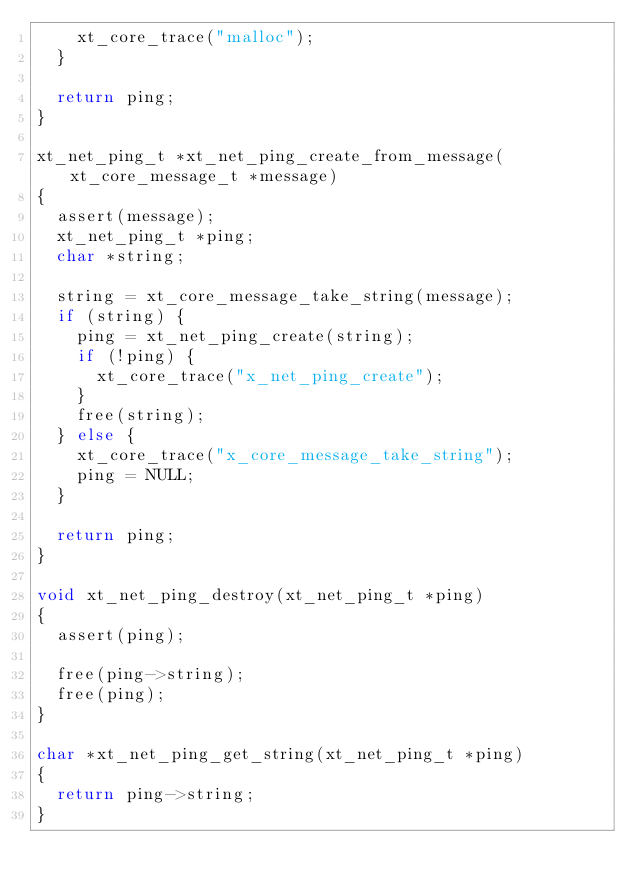<code> <loc_0><loc_0><loc_500><loc_500><_C_>    xt_core_trace("malloc");
  }

  return ping;
}

xt_net_ping_t *xt_net_ping_create_from_message(xt_core_message_t *message)
{
  assert(message);
  xt_net_ping_t *ping;
  char *string;

  string = xt_core_message_take_string(message);
  if (string) {
    ping = xt_net_ping_create(string);
    if (!ping) {
      xt_core_trace("x_net_ping_create");
    }
    free(string);
  } else {
    xt_core_trace("x_core_message_take_string");
    ping = NULL;
  }

  return ping;
}

void xt_net_ping_destroy(xt_net_ping_t *ping)
{
  assert(ping);

  free(ping->string);
  free(ping);
}

char *xt_net_ping_get_string(xt_net_ping_t *ping)
{
  return ping->string;
}
</code> 